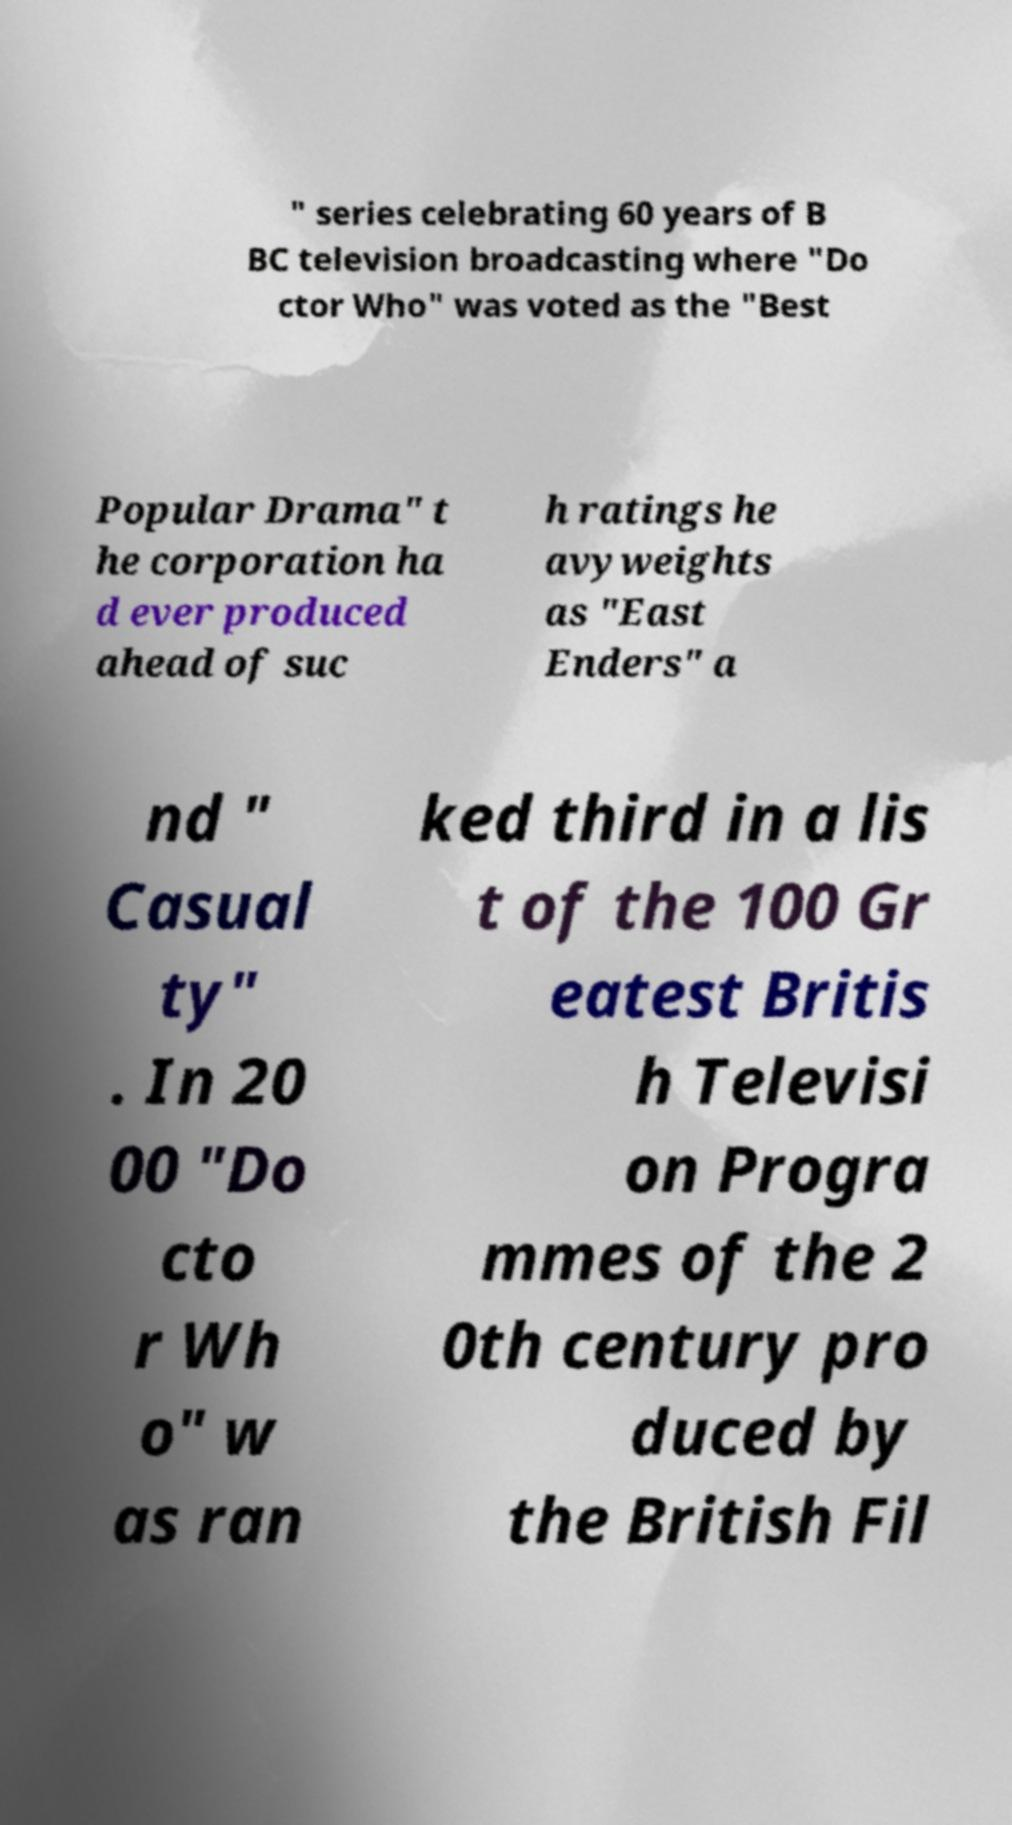Can you read and provide the text displayed in the image?This photo seems to have some interesting text. Can you extract and type it out for me? " series celebrating 60 years of B BC television broadcasting where "Do ctor Who" was voted as the "Best Popular Drama" t he corporation ha d ever produced ahead of suc h ratings he avyweights as "East Enders" a nd " Casual ty" . In 20 00 "Do cto r Wh o" w as ran ked third in a lis t of the 100 Gr eatest Britis h Televisi on Progra mmes of the 2 0th century pro duced by the British Fil 